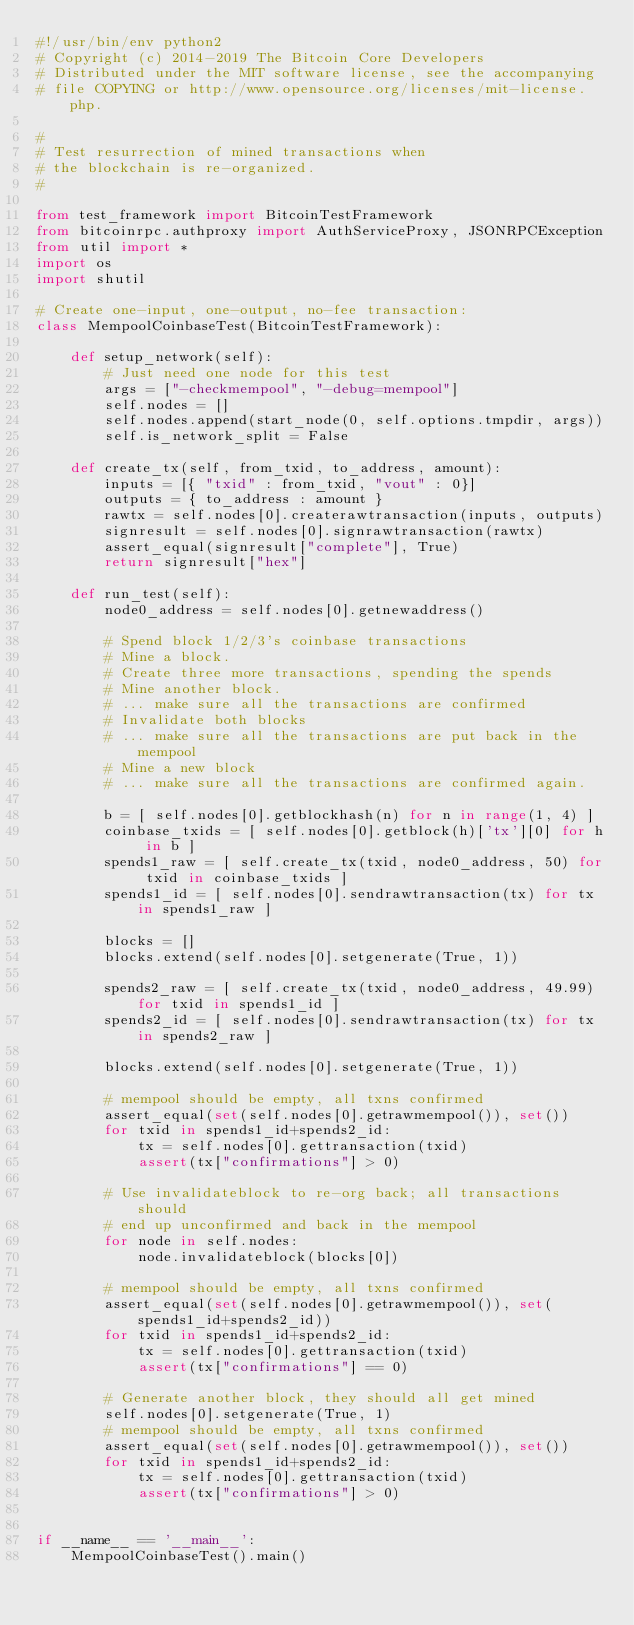<code> <loc_0><loc_0><loc_500><loc_500><_Python_>#!/usr/bin/env python2
# Copyright (c) 2014-2019 The Bitcoin Core Developers
# Distributed under the MIT software license, see the accompanying
# file COPYING or http://www.opensource.org/licenses/mit-license.php.

#
# Test resurrection of mined transactions when
# the blockchain is re-organized.
#

from test_framework import BitcoinTestFramework
from bitcoinrpc.authproxy import AuthServiceProxy, JSONRPCException
from util import *
import os
import shutil

# Create one-input, one-output, no-fee transaction:
class MempoolCoinbaseTest(BitcoinTestFramework):

    def setup_network(self):
        # Just need one node for this test
        args = ["-checkmempool", "-debug=mempool"]
        self.nodes = []
        self.nodes.append(start_node(0, self.options.tmpdir, args))
        self.is_network_split = False

    def create_tx(self, from_txid, to_address, amount):
        inputs = [{ "txid" : from_txid, "vout" : 0}]
        outputs = { to_address : amount }
        rawtx = self.nodes[0].createrawtransaction(inputs, outputs)
        signresult = self.nodes[0].signrawtransaction(rawtx)
        assert_equal(signresult["complete"], True)
        return signresult["hex"]

    def run_test(self):
        node0_address = self.nodes[0].getnewaddress()

        # Spend block 1/2/3's coinbase transactions
        # Mine a block.
        # Create three more transactions, spending the spends
        # Mine another block.
        # ... make sure all the transactions are confirmed
        # Invalidate both blocks
        # ... make sure all the transactions are put back in the mempool
        # Mine a new block
        # ... make sure all the transactions are confirmed again.

        b = [ self.nodes[0].getblockhash(n) for n in range(1, 4) ]
        coinbase_txids = [ self.nodes[0].getblock(h)['tx'][0] for h in b ]
        spends1_raw = [ self.create_tx(txid, node0_address, 50) for txid in coinbase_txids ]
        spends1_id = [ self.nodes[0].sendrawtransaction(tx) for tx in spends1_raw ]

        blocks = []
        blocks.extend(self.nodes[0].setgenerate(True, 1))

        spends2_raw = [ self.create_tx(txid, node0_address, 49.99) for txid in spends1_id ]
        spends2_id = [ self.nodes[0].sendrawtransaction(tx) for tx in spends2_raw ]

        blocks.extend(self.nodes[0].setgenerate(True, 1))

        # mempool should be empty, all txns confirmed
        assert_equal(set(self.nodes[0].getrawmempool()), set())
        for txid in spends1_id+spends2_id:
            tx = self.nodes[0].gettransaction(txid)
            assert(tx["confirmations"] > 0)

        # Use invalidateblock to re-org back; all transactions should
        # end up unconfirmed and back in the mempool
        for node in self.nodes:
            node.invalidateblock(blocks[0])

        # mempool should be empty, all txns confirmed
        assert_equal(set(self.nodes[0].getrawmempool()), set(spends1_id+spends2_id))
        for txid in spends1_id+spends2_id:
            tx = self.nodes[0].gettransaction(txid)
            assert(tx["confirmations"] == 0)

        # Generate another block, they should all get mined
        self.nodes[0].setgenerate(True, 1)
        # mempool should be empty, all txns confirmed
        assert_equal(set(self.nodes[0].getrawmempool()), set())
        for txid in spends1_id+spends2_id:
            tx = self.nodes[0].gettransaction(txid)
            assert(tx["confirmations"] > 0)


if __name__ == '__main__':
    MempoolCoinbaseTest().main()
</code> 